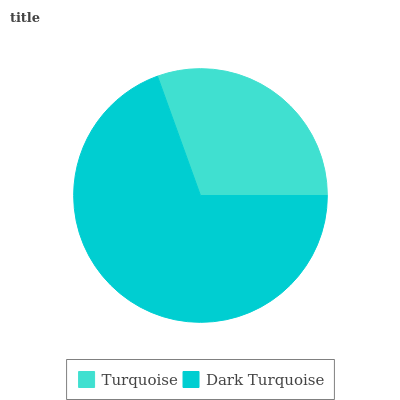Is Turquoise the minimum?
Answer yes or no. Yes. Is Dark Turquoise the maximum?
Answer yes or no. Yes. Is Dark Turquoise the minimum?
Answer yes or no. No. Is Dark Turquoise greater than Turquoise?
Answer yes or no. Yes. Is Turquoise less than Dark Turquoise?
Answer yes or no. Yes. Is Turquoise greater than Dark Turquoise?
Answer yes or no. No. Is Dark Turquoise less than Turquoise?
Answer yes or no. No. Is Dark Turquoise the high median?
Answer yes or no. Yes. Is Turquoise the low median?
Answer yes or no. Yes. Is Turquoise the high median?
Answer yes or no. No. Is Dark Turquoise the low median?
Answer yes or no. No. 